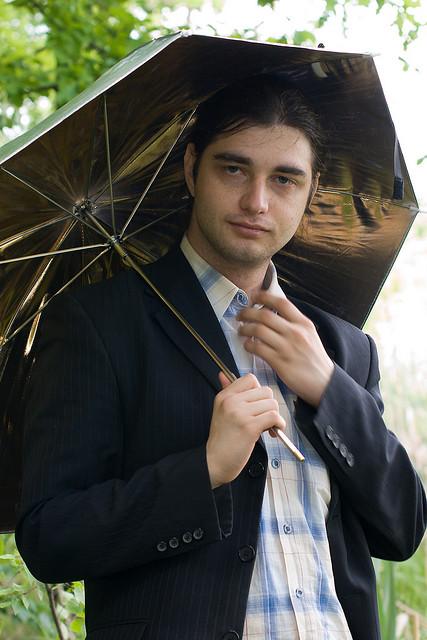Is the man wearing a hat?
Be succinct. No. What is the man looking at?
Write a very short answer. Camera. What is missing from the umbrella?
Keep it brief. Handle. 